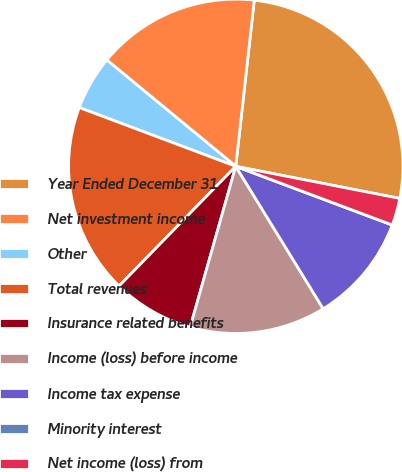Convert chart. <chart><loc_0><loc_0><loc_500><loc_500><pie_chart><fcel>Year Ended December 31<fcel>Net investment income<fcel>Other<fcel>Total revenues<fcel>Insurance related benefits<fcel>Income (loss) before income<fcel>Income tax expense<fcel>Minority interest<fcel>Net income (loss) from<nl><fcel>26.31%<fcel>15.79%<fcel>5.26%<fcel>18.42%<fcel>7.9%<fcel>13.16%<fcel>10.53%<fcel>0.0%<fcel>2.63%<nl></chart> 